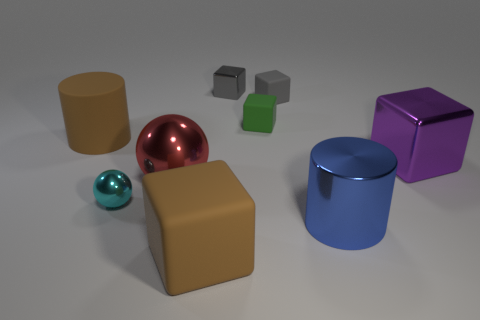Subtract all large purple blocks. How many blocks are left? 4 Subtract 1 spheres. How many spheres are left? 1 Subtract all cyan balls. How many balls are left? 1 Subtract all balls. How many objects are left? 7 Subtract all small rubber blocks. Subtract all big matte cylinders. How many objects are left? 6 Add 7 tiny metallic things. How many tiny metallic things are left? 9 Add 2 small cyan rubber spheres. How many small cyan rubber spheres exist? 2 Add 1 green blocks. How many objects exist? 10 Subtract 1 green cubes. How many objects are left? 8 Subtract all blue cubes. Subtract all red cylinders. How many cubes are left? 5 